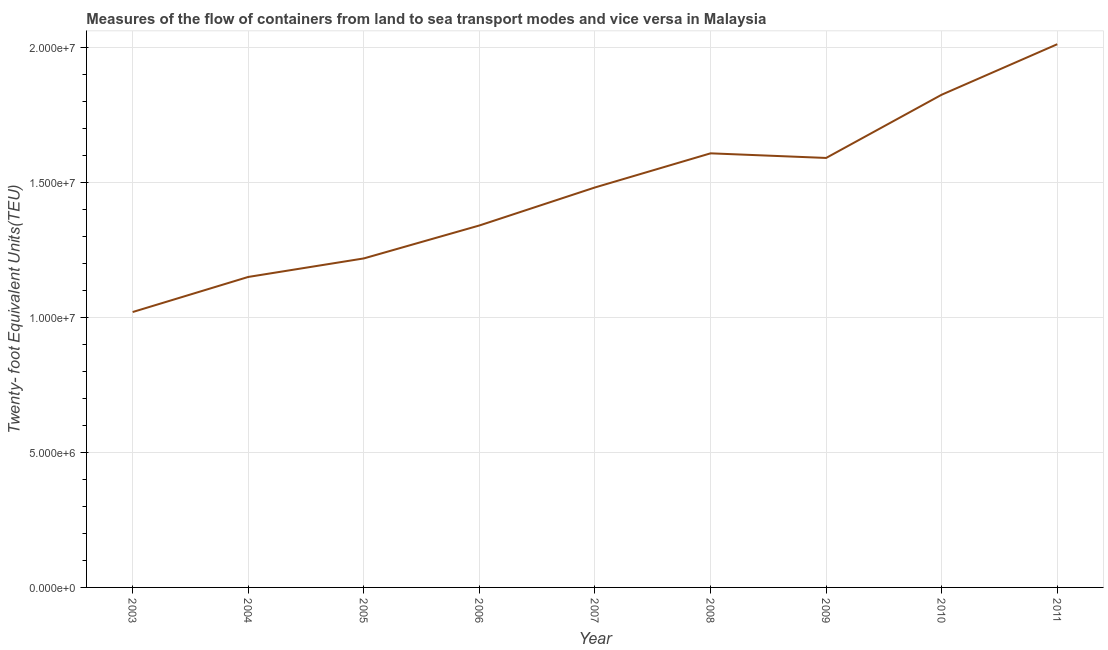What is the container port traffic in 2006?
Your answer should be compact. 1.34e+07. Across all years, what is the maximum container port traffic?
Your answer should be very brief. 2.01e+07. Across all years, what is the minimum container port traffic?
Offer a very short reply. 1.02e+07. What is the sum of the container port traffic?
Offer a terse response. 1.33e+08. What is the difference between the container port traffic in 2009 and 2010?
Make the answer very short. -2.34e+06. What is the average container port traffic per year?
Make the answer very short. 1.47e+07. What is the median container port traffic?
Offer a very short reply. 1.48e+07. Do a majority of the years between 2004 and 2008 (inclusive) have container port traffic greater than 11000000 TEU?
Your response must be concise. Yes. What is the ratio of the container port traffic in 2004 to that in 2006?
Make the answer very short. 0.86. Is the difference between the container port traffic in 2003 and 2011 greater than the difference between any two years?
Your answer should be very brief. Yes. What is the difference between the highest and the second highest container port traffic?
Provide a short and direct response. 1.87e+06. Is the sum of the container port traffic in 2005 and 2007 greater than the maximum container port traffic across all years?
Offer a terse response. Yes. What is the difference between the highest and the lowest container port traffic?
Your response must be concise. 9.93e+06. In how many years, is the container port traffic greater than the average container port traffic taken over all years?
Give a very brief answer. 5. Does the container port traffic monotonically increase over the years?
Your answer should be very brief. No. How many years are there in the graph?
Offer a very short reply. 9. Are the values on the major ticks of Y-axis written in scientific E-notation?
Offer a terse response. Yes. Does the graph contain any zero values?
Offer a very short reply. No. Does the graph contain grids?
Keep it short and to the point. Yes. What is the title of the graph?
Provide a succinct answer. Measures of the flow of containers from land to sea transport modes and vice versa in Malaysia. What is the label or title of the Y-axis?
Offer a terse response. Twenty- foot Equivalent Units(TEU). What is the Twenty- foot Equivalent Units(TEU) of 2003?
Your answer should be compact. 1.02e+07. What is the Twenty- foot Equivalent Units(TEU) in 2004?
Give a very brief answer. 1.15e+07. What is the Twenty- foot Equivalent Units(TEU) in 2005?
Your answer should be very brief. 1.22e+07. What is the Twenty- foot Equivalent Units(TEU) in 2006?
Offer a terse response. 1.34e+07. What is the Twenty- foot Equivalent Units(TEU) of 2007?
Give a very brief answer. 1.48e+07. What is the Twenty- foot Equivalent Units(TEU) in 2008?
Ensure brevity in your answer.  1.61e+07. What is the Twenty- foot Equivalent Units(TEU) of 2009?
Offer a very short reply. 1.59e+07. What is the Twenty- foot Equivalent Units(TEU) of 2010?
Offer a terse response. 1.83e+07. What is the Twenty- foot Equivalent Units(TEU) of 2011?
Provide a succinct answer. 2.01e+07. What is the difference between the Twenty- foot Equivalent Units(TEU) in 2003 and 2004?
Keep it short and to the point. -1.30e+06. What is the difference between the Twenty- foot Equivalent Units(TEU) in 2003 and 2005?
Give a very brief answer. -1.99e+06. What is the difference between the Twenty- foot Equivalent Units(TEU) in 2003 and 2006?
Your answer should be compact. -3.21e+06. What is the difference between the Twenty- foot Equivalent Units(TEU) in 2003 and 2007?
Ensure brevity in your answer.  -4.62e+06. What is the difference between the Twenty- foot Equivalent Units(TEU) in 2003 and 2008?
Your answer should be very brief. -5.88e+06. What is the difference between the Twenty- foot Equivalent Units(TEU) in 2003 and 2009?
Provide a succinct answer. -5.71e+06. What is the difference between the Twenty- foot Equivalent Units(TEU) in 2003 and 2010?
Your answer should be compact. -8.06e+06. What is the difference between the Twenty- foot Equivalent Units(TEU) in 2003 and 2011?
Provide a succinct answer. -9.93e+06. What is the difference between the Twenty- foot Equivalent Units(TEU) in 2004 and 2005?
Offer a terse response. -6.87e+05. What is the difference between the Twenty- foot Equivalent Units(TEU) in 2004 and 2006?
Ensure brevity in your answer.  -1.91e+06. What is the difference between the Twenty- foot Equivalent Units(TEU) in 2004 and 2007?
Ensure brevity in your answer.  -3.32e+06. What is the difference between the Twenty- foot Equivalent Units(TEU) in 2004 and 2008?
Your answer should be very brief. -4.58e+06. What is the difference between the Twenty- foot Equivalent Units(TEU) in 2004 and 2009?
Offer a very short reply. -4.41e+06. What is the difference between the Twenty- foot Equivalent Units(TEU) in 2004 and 2010?
Your response must be concise. -6.76e+06. What is the difference between the Twenty- foot Equivalent Units(TEU) in 2004 and 2011?
Offer a very short reply. -8.63e+06. What is the difference between the Twenty- foot Equivalent Units(TEU) in 2005 and 2006?
Your response must be concise. -1.22e+06. What is the difference between the Twenty- foot Equivalent Units(TEU) in 2005 and 2007?
Offer a very short reply. -2.63e+06. What is the difference between the Twenty- foot Equivalent Units(TEU) in 2005 and 2008?
Offer a terse response. -3.90e+06. What is the difference between the Twenty- foot Equivalent Units(TEU) in 2005 and 2009?
Make the answer very short. -3.73e+06. What is the difference between the Twenty- foot Equivalent Units(TEU) in 2005 and 2010?
Ensure brevity in your answer.  -6.07e+06. What is the difference between the Twenty- foot Equivalent Units(TEU) in 2005 and 2011?
Offer a terse response. -7.94e+06. What is the difference between the Twenty- foot Equivalent Units(TEU) in 2006 and 2007?
Your response must be concise. -1.41e+06. What is the difference between the Twenty- foot Equivalent Units(TEU) in 2006 and 2008?
Offer a very short reply. -2.67e+06. What is the difference between the Twenty- foot Equivalent Units(TEU) in 2006 and 2009?
Keep it short and to the point. -2.50e+06. What is the difference between the Twenty- foot Equivalent Units(TEU) in 2006 and 2010?
Make the answer very short. -4.85e+06. What is the difference between the Twenty- foot Equivalent Units(TEU) in 2006 and 2011?
Provide a short and direct response. -6.72e+06. What is the difference between the Twenty- foot Equivalent Units(TEU) in 2007 and 2008?
Provide a succinct answer. -1.27e+06. What is the difference between the Twenty- foot Equivalent Units(TEU) in 2007 and 2009?
Provide a succinct answer. -1.09e+06. What is the difference between the Twenty- foot Equivalent Units(TEU) in 2007 and 2010?
Offer a terse response. -3.44e+06. What is the difference between the Twenty- foot Equivalent Units(TEU) in 2007 and 2011?
Keep it short and to the point. -5.31e+06. What is the difference between the Twenty- foot Equivalent Units(TEU) in 2008 and 2009?
Keep it short and to the point. 1.71e+05. What is the difference between the Twenty- foot Equivalent Units(TEU) in 2008 and 2010?
Your response must be concise. -2.17e+06. What is the difference between the Twenty- foot Equivalent Units(TEU) in 2008 and 2011?
Make the answer very short. -4.05e+06. What is the difference between the Twenty- foot Equivalent Units(TEU) in 2009 and 2010?
Offer a very short reply. -2.34e+06. What is the difference between the Twenty- foot Equivalent Units(TEU) in 2009 and 2011?
Your response must be concise. -4.22e+06. What is the difference between the Twenty- foot Equivalent Units(TEU) in 2010 and 2011?
Ensure brevity in your answer.  -1.87e+06. What is the ratio of the Twenty- foot Equivalent Units(TEU) in 2003 to that in 2004?
Offer a very short reply. 0.89. What is the ratio of the Twenty- foot Equivalent Units(TEU) in 2003 to that in 2005?
Offer a terse response. 0.84. What is the ratio of the Twenty- foot Equivalent Units(TEU) in 2003 to that in 2006?
Your answer should be very brief. 0.76. What is the ratio of the Twenty- foot Equivalent Units(TEU) in 2003 to that in 2007?
Offer a terse response. 0.69. What is the ratio of the Twenty- foot Equivalent Units(TEU) in 2003 to that in 2008?
Offer a terse response. 0.63. What is the ratio of the Twenty- foot Equivalent Units(TEU) in 2003 to that in 2009?
Keep it short and to the point. 0.64. What is the ratio of the Twenty- foot Equivalent Units(TEU) in 2003 to that in 2010?
Your answer should be compact. 0.56. What is the ratio of the Twenty- foot Equivalent Units(TEU) in 2003 to that in 2011?
Your answer should be very brief. 0.51. What is the ratio of the Twenty- foot Equivalent Units(TEU) in 2004 to that in 2005?
Give a very brief answer. 0.94. What is the ratio of the Twenty- foot Equivalent Units(TEU) in 2004 to that in 2006?
Your response must be concise. 0.86. What is the ratio of the Twenty- foot Equivalent Units(TEU) in 2004 to that in 2007?
Give a very brief answer. 0.78. What is the ratio of the Twenty- foot Equivalent Units(TEU) in 2004 to that in 2008?
Your response must be concise. 0.71. What is the ratio of the Twenty- foot Equivalent Units(TEU) in 2004 to that in 2009?
Offer a terse response. 0.72. What is the ratio of the Twenty- foot Equivalent Units(TEU) in 2004 to that in 2010?
Offer a terse response. 0.63. What is the ratio of the Twenty- foot Equivalent Units(TEU) in 2004 to that in 2011?
Your response must be concise. 0.57. What is the ratio of the Twenty- foot Equivalent Units(TEU) in 2005 to that in 2006?
Your response must be concise. 0.91. What is the ratio of the Twenty- foot Equivalent Units(TEU) in 2005 to that in 2007?
Offer a very short reply. 0.82. What is the ratio of the Twenty- foot Equivalent Units(TEU) in 2005 to that in 2008?
Offer a very short reply. 0.76. What is the ratio of the Twenty- foot Equivalent Units(TEU) in 2005 to that in 2009?
Make the answer very short. 0.77. What is the ratio of the Twenty- foot Equivalent Units(TEU) in 2005 to that in 2010?
Ensure brevity in your answer.  0.67. What is the ratio of the Twenty- foot Equivalent Units(TEU) in 2005 to that in 2011?
Ensure brevity in your answer.  0.61. What is the ratio of the Twenty- foot Equivalent Units(TEU) in 2006 to that in 2007?
Your response must be concise. 0.91. What is the ratio of the Twenty- foot Equivalent Units(TEU) in 2006 to that in 2008?
Provide a succinct answer. 0.83. What is the ratio of the Twenty- foot Equivalent Units(TEU) in 2006 to that in 2009?
Offer a very short reply. 0.84. What is the ratio of the Twenty- foot Equivalent Units(TEU) in 2006 to that in 2010?
Make the answer very short. 0.73. What is the ratio of the Twenty- foot Equivalent Units(TEU) in 2006 to that in 2011?
Provide a short and direct response. 0.67. What is the ratio of the Twenty- foot Equivalent Units(TEU) in 2007 to that in 2008?
Keep it short and to the point. 0.92. What is the ratio of the Twenty- foot Equivalent Units(TEU) in 2007 to that in 2009?
Provide a short and direct response. 0.93. What is the ratio of the Twenty- foot Equivalent Units(TEU) in 2007 to that in 2010?
Offer a terse response. 0.81. What is the ratio of the Twenty- foot Equivalent Units(TEU) in 2007 to that in 2011?
Provide a short and direct response. 0.74. What is the ratio of the Twenty- foot Equivalent Units(TEU) in 2008 to that in 2010?
Offer a very short reply. 0.88. What is the ratio of the Twenty- foot Equivalent Units(TEU) in 2008 to that in 2011?
Ensure brevity in your answer.  0.8. What is the ratio of the Twenty- foot Equivalent Units(TEU) in 2009 to that in 2010?
Your answer should be very brief. 0.87. What is the ratio of the Twenty- foot Equivalent Units(TEU) in 2009 to that in 2011?
Your answer should be compact. 0.79. What is the ratio of the Twenty- foot Equivalent Units(TEU) in 2010 to that in 2011?
Provide a short and direct response. 0.91. 